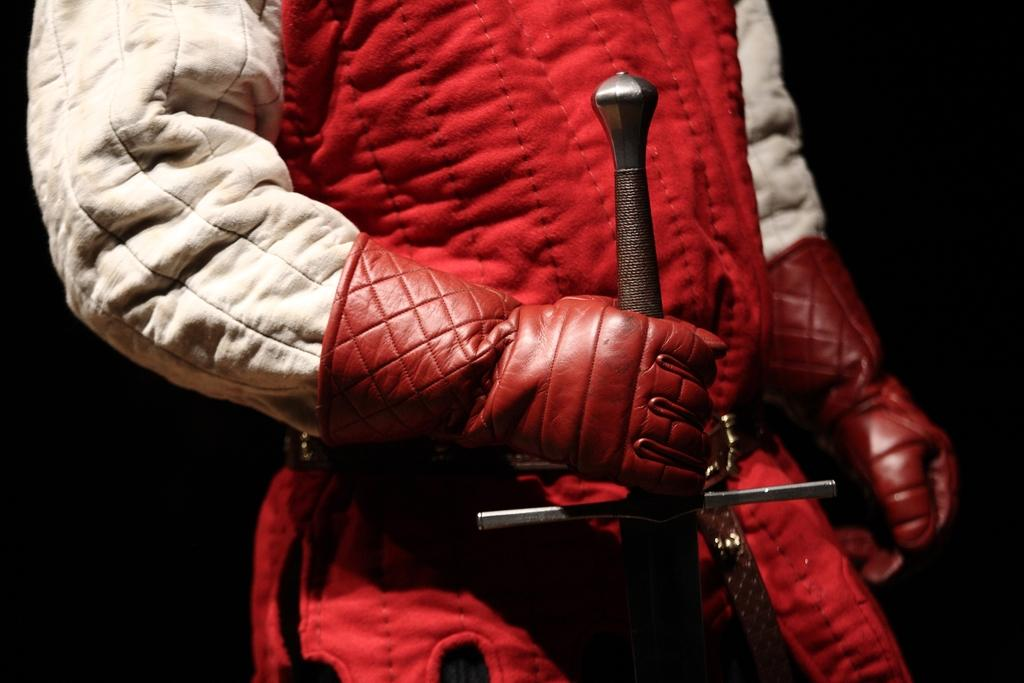What can be seen in the image? There is a person in the image. What is the person wearing? The person is wearing gloves. What is the person holding? The person is holding an object. How would you describe the background of the image? The background of the image is dark. What type of tax is being discussed in the image? There is no mention of tax or any discussion in the image; it features a person wearing gloves and holding an object against a dark background. 